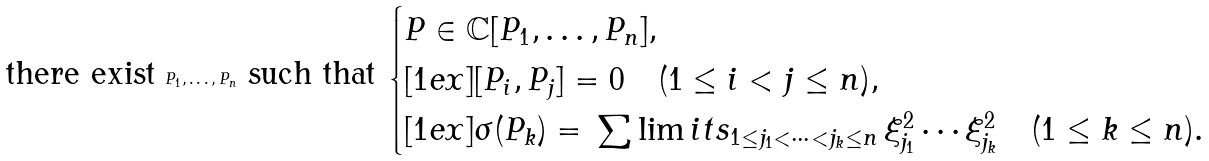<formula> <loc_0><loc_0><loc_500><loc_500>\text {there exist } P _ { 1 } , \dots , P _ { n } \text { such that } \begin{cases} P \in \mathbb { C } [ P _ { 1 } , \dots , P _ { n } ] , \\ [ 1 e x ] [ P _ { i } , P _ { j } ] = 0 \quad ( 1 \leq i < j \leq n ) , \\ [ 1 e x ] \sigma ( P _ { k } ) = \, \sum \lim i t s _ { 1 \leq j _ { 1 } < \dots < j _ { k } \leq n } \, \xi _ { j _ { 1 } } ^ { 2 } \cdots \xi _ { j _ { k } } ^ { 2 } \quad ( 1 \leq k \leq n ) . \end{cases}</formula> 